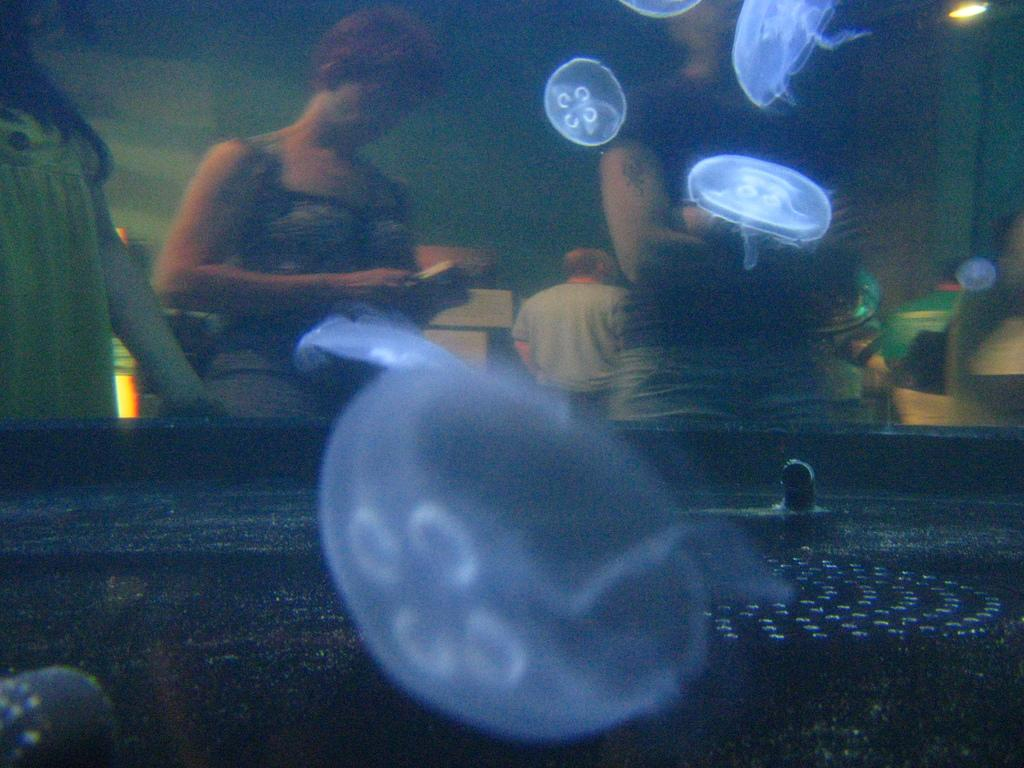What is in the water in the foreground of the image? There are jellyfishes in the water in the foreground of the image. What separates the persons from the water in the image? There is a glass barrier in the image. Who is behind the glass barrier? There are persons standing behind the glass barrier. What can be seen through the glass barrier? A wall and objects are visible through the glass barrier. Can you see a flock of birds flying behind the glass barrier in the image? There is no mention of birds or a flock in the image; it features jellyfishes in the water and a glass barrier with persons standing behind it. Are there any socks visible in the image? There is no mention of socks in the image; it focuses on jellyfishes, a glass barrier, and persons standing behind it. 